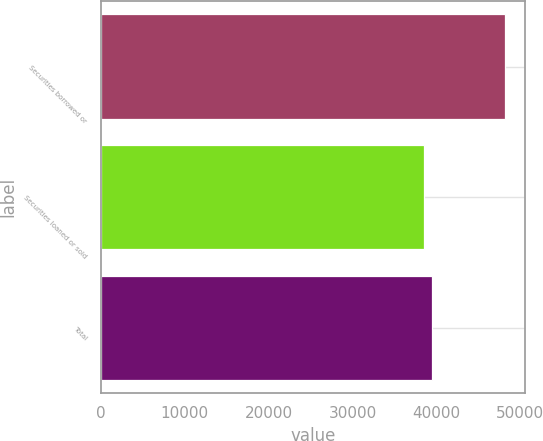Convert chart. <chart><loc_0><loc_0><loc_500><loc_500><bar_chart><fcel>Securities borrowed or<fcel>Securities loaned or sold<fcel>Total<nl><fcel>48150<fcel>38542<fcel>39502.8<nl></chart> 